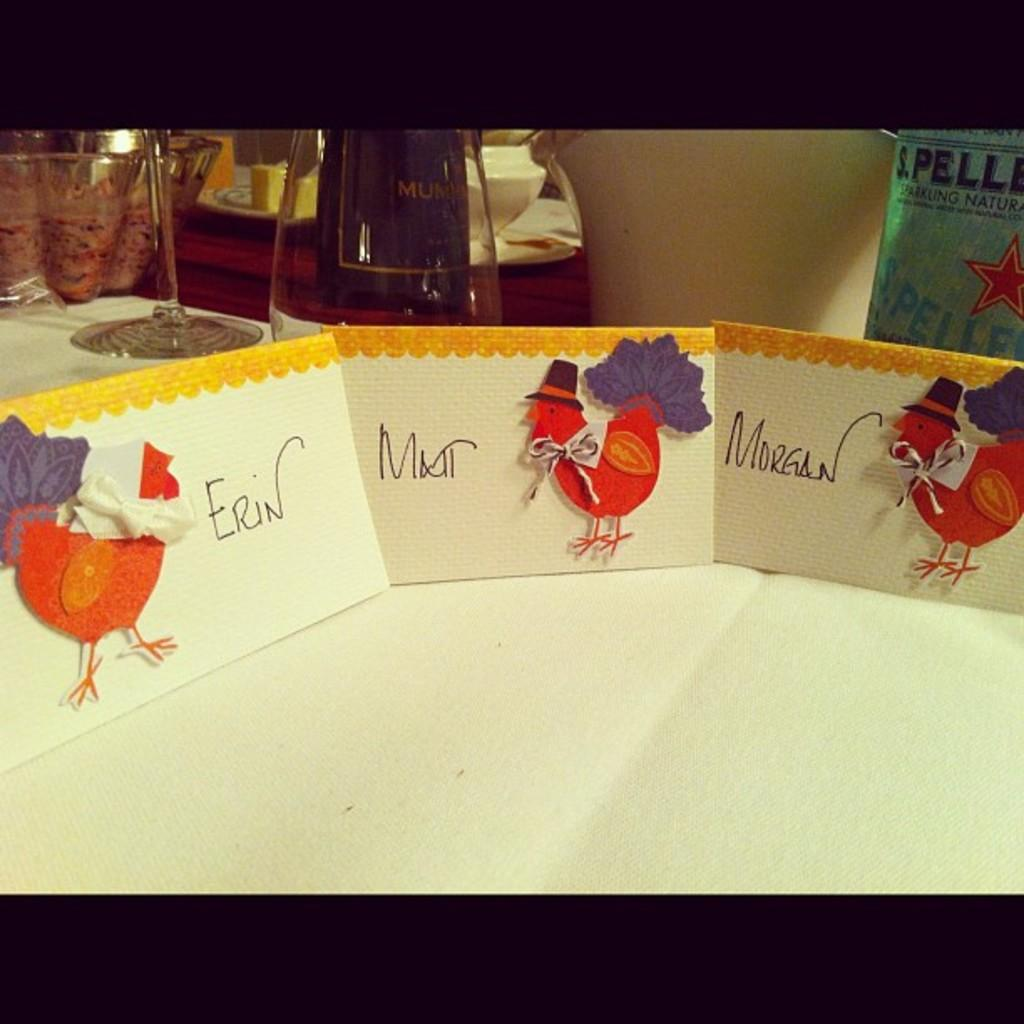<image>
Describe the image concisely. turkey cards are on the table with Erins on the far left 